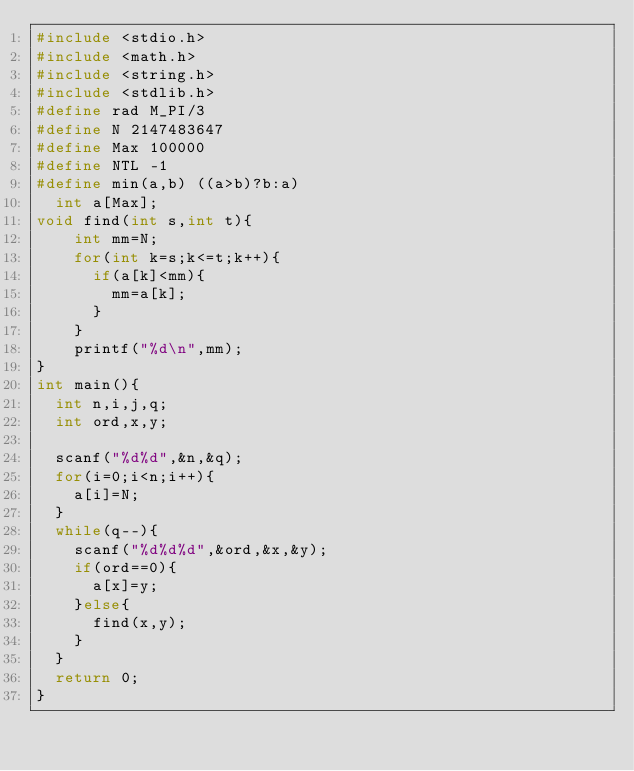Convert code to text. <code><loc_0><loc_0><loc_500><loc_500><_C_>#include <stdio.h>
#include <math.h>
#include <string.h>
#include <stdlib.h>
#define rad M_PI/3
#define N 2147483647
#define Max 100000
#define NTL -1
#define min(a,b) ((a>b)?b:a)
  int a[Max];
void find(int s,int t){
    int mm=N;
    for(int k=s;k<=t;k++){
      if(a[k]<mm){
        mm=a[k];
      }
    }
    printf("%d\n",mm);
}
int main(){
  int n,i,j,q;
  int ord,x,y;

  scanf("%d%d",&n,&q);
  for(i=0;i<n;i++){
    a[i]=N;
  }
  while(q--){
    scanf("%d%d%d",&ord,&x,&y);
    if(ord==0){
      a[x]=y;
    }else{
      find(x,y);
    }
  }
  return 0;
}
</code> 